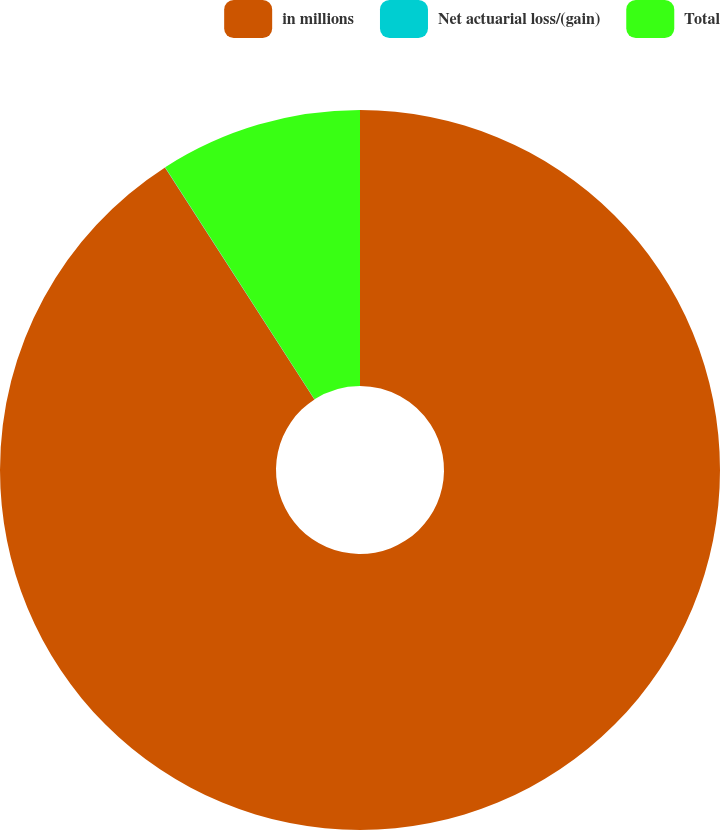<chart> <loc_0><loc_0><loc_500><loc_500><pie_chart><fcel>in millions<fcel>Net actuarial loss/(gain)<fcel>Total<nl><fcel>90.89%<fcel>0.01%<fcel>9.1%<nl></chart> 